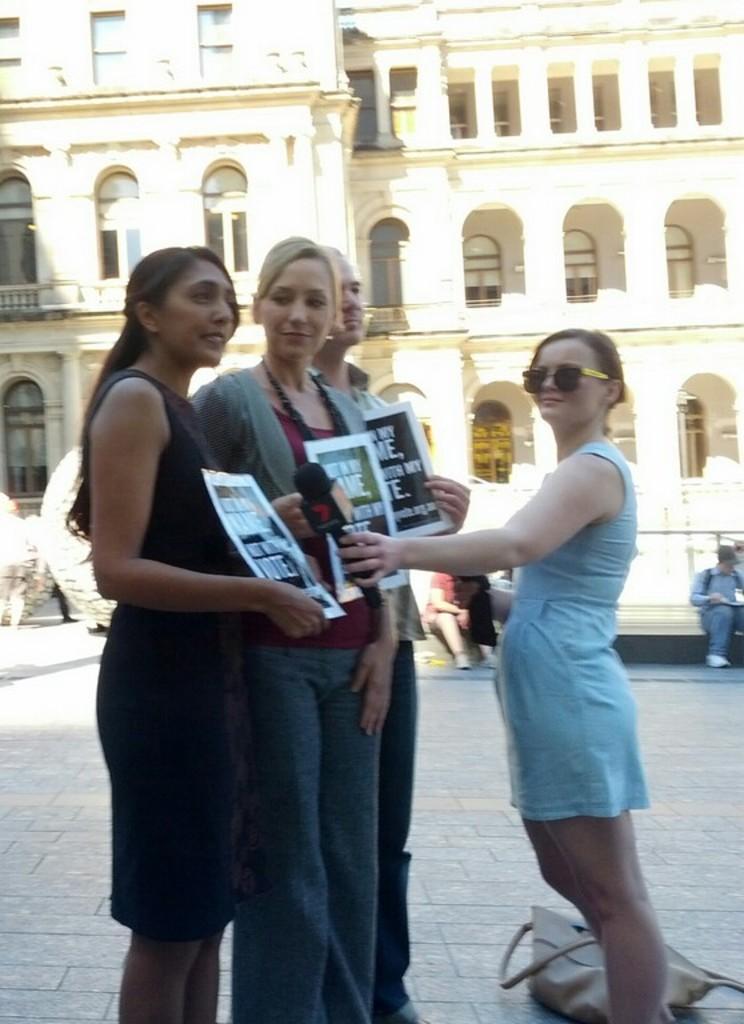Describe this image in one or two sentences. This picture is taken from the outside of the building and it is sunny. In this image, in the middle, we can see four people are standing on the floor and holding some objects in their hand. On the right side bottom, we can also see a handbag. In the background, we can see a group of people, building, glass window. 